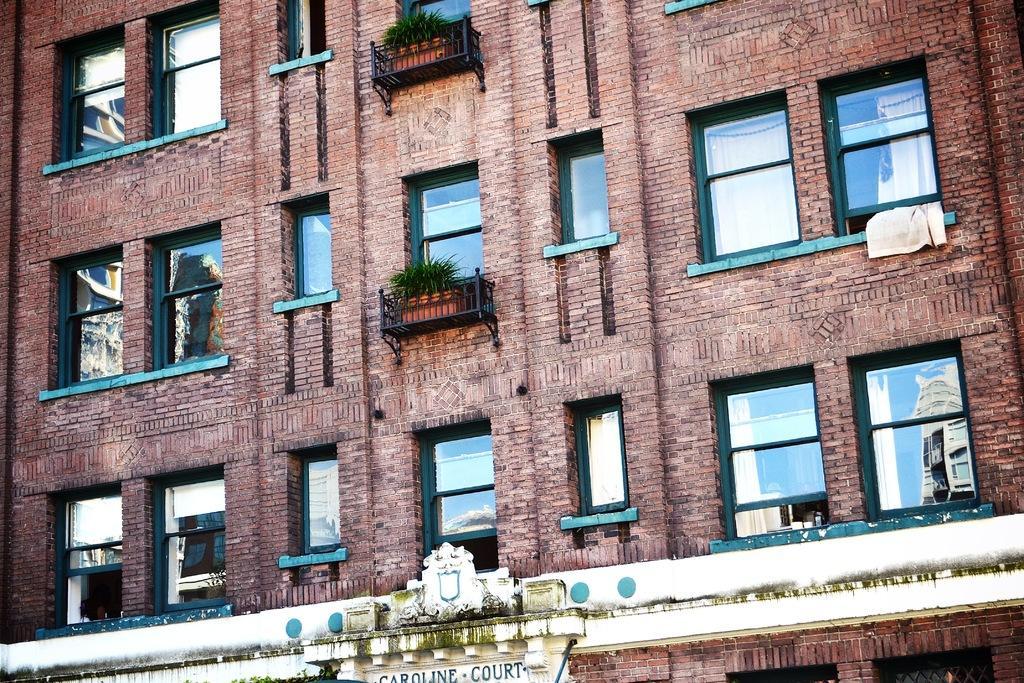Please provide a concise description of this image. In this image I can see a building along with the windows. Here I can see some plants as well. At the bottom of the image I can see a name board to the wall. 